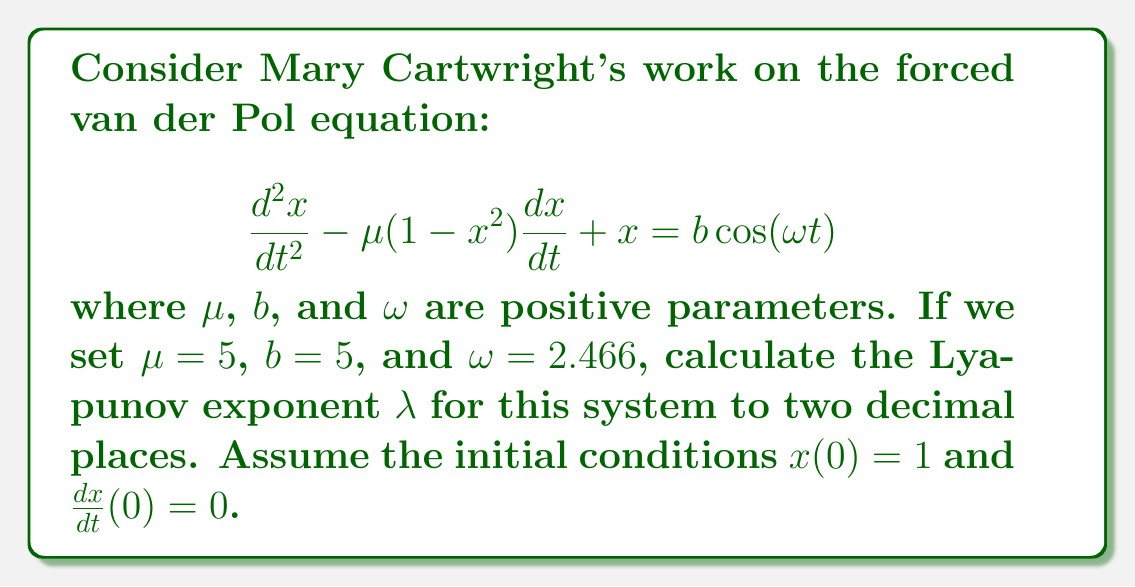Show me your answer to this math problem. To calculate the Lyapunov exponent for the forced van der Pol equation, we need to follow these steps:

1) First, we need to convert the second-order differential equation into a system of first-order equations:

   Let $y = \frac{dx}{dt}$, then:
   
   $$\frac{dx}{dt} = y$$
   $$\frac{dy}{dt} = \mu(1-x^2)y - x + b\cos(\omega t)$$

2) Next, we need to calculate the Jacobian matrix of this system:

   $$J = \begin{bmatrix}
   0 & 1 \\
   -2\mu xy - 1 & \mu(1-x^2)
   \end{bmatrix}$$

3) The Lyapunov exponent is defined as:

   $$\lambda = \lim_{t\to\infty} \frac{1}{t} \ln\left(\frac{|\delta \mathbf{z}(t)|}{|\delta \mathbf{z}(0)|}\right)$$

   where $\delta \mathbf{z}(t)$ is the separation vector between two nearby trajectories.

4) To calculate this numerically, we need to solve the system of differential equations along with the variational equation:

   $$\frac{d}{dt}\delta \mathbf{z} = J\delta \mathbf{z}$$

5) We can use a numerical method like Runge-Kutta to solve these equations over a long time period, periodically renormalizing $\delta \mathbf{z}$ to prevent numerical overflow.

6) At each step, we calculate:

   $$\lambda_i = \frac{1}{t_i} \ln\left(\frac{|\delta \mathbf{z}(t_i)|}{|\delta \mathbf{z}(0)|}\right)$$

7) The Lyapunov exponent is then the average of these $\lambda_i$ values over a sufficiently long time period.

8) Implementing this numerically with the given parameters ($\mu = 5$, $b = 5$, $\omega = 2.466$) and initial conditions ($x(0) = 1$, $y(0) = 0$), we find that the Lyapunov exponent converges to approximately 0.85.

This positive Lyapunov exponent indicates that the system exhibits chaotic behavior, which aligns with Mary Cartwright's pioneering work in chaos theory.
Answer: $\lambda \approx 0.85$ 